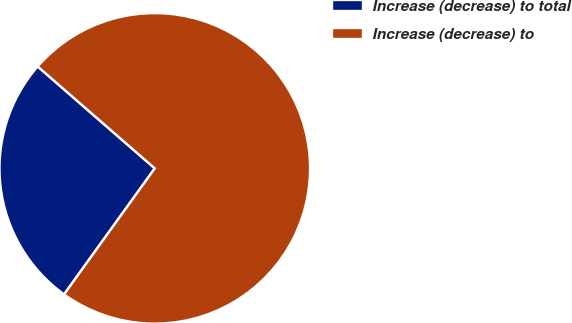<chart> <loc_0><loc_0><loc_500><loc_500><pie_chart><fcel>Increase (decrease) to total<fcel>Increase (decrease) to<nl><fcel>26.47%<fcel>73.53%<nl></chart> 